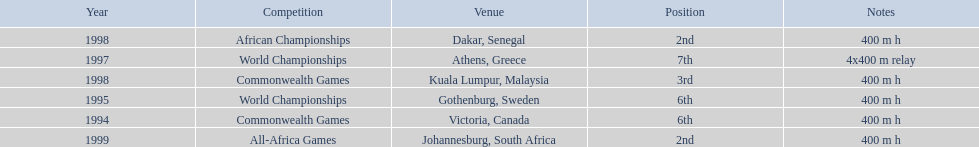What races did ken harden run? 400 m h, 400 m h, 4x400 m relay, 400 m h, 400 m h, 400 m h. Which race did ken harden run in 1997? 4x400 m relay. 